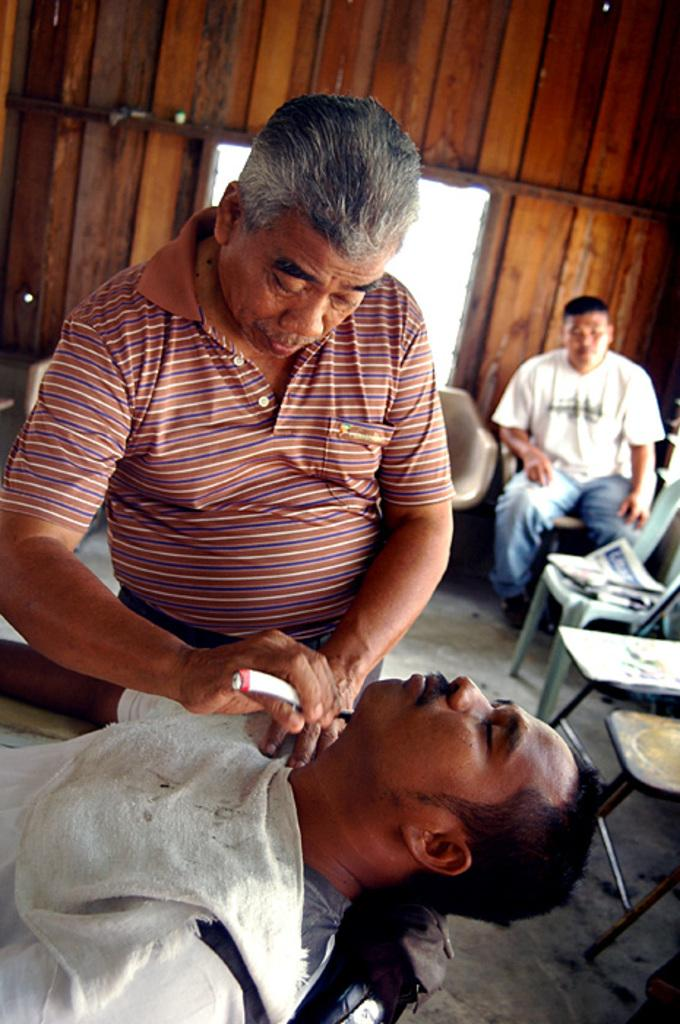How many people are in the image? There are people in the image. What are the people doing in the image? Two people are sitting on chairs, and one person is holding an object. What type of furniture is present in the image? There are chairs in the image. What can be seen on the floor in the image? There is a newspaper visible on the floor. What type of wall is present in the image? There is a wooden wall in the image. What architectural feature is present in the image? There is a window in the image. What time of day is it in the image, and are the people kissing? The time of day is not mentioned in the image, and there is no indication of people kissing. Is there a basketball visible in the image? There is no basketball present in the image. 